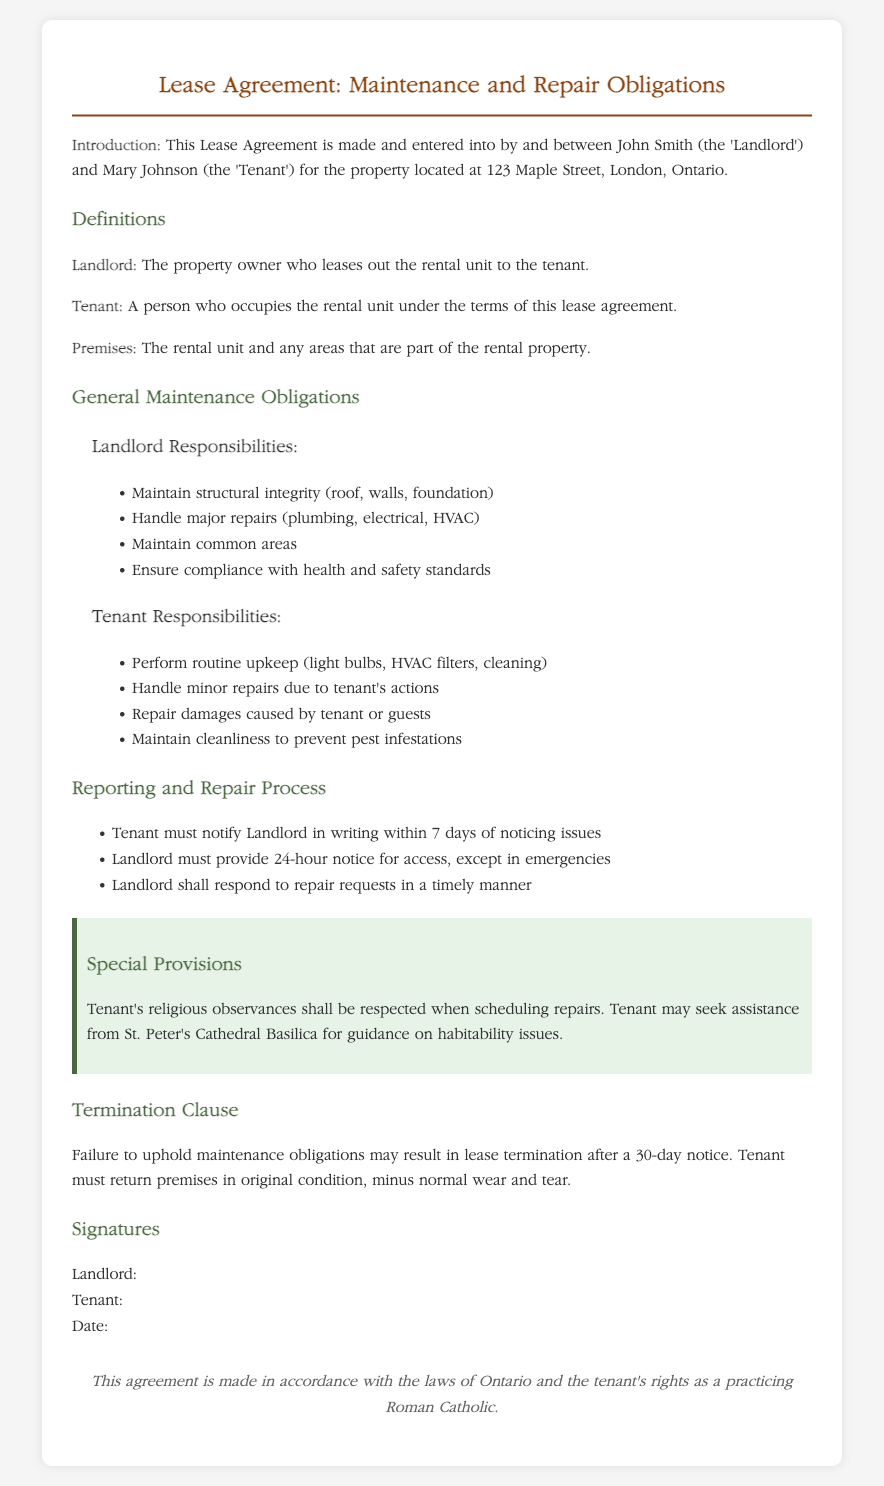What are the names of the landlord and tenant? The document states the landlord is John Smith and the tenant is Mary Johnson.
Answer: John Smith and Mary Johnson What is the address of the property? The property address listed in the document is part of the introduction section.
Answer: 123 Maple Street, London, Ontario What must the tenant do within 7 days of noticing issues? The document specifies that the tenant must notify the landlord in writing about issues.
Answer: Notify in writing Who is responsible for maintaining common areas? This responsibility is outlined under the landlord's obligations in the general maintenance section.
Answer: Landlord What is the notice period for the landlord to provide access for repairs? The relevant section mentions the need for 24-hour notice before landlord access, excluding emergencies.
Answer: 24-hour notice What happens if the maintenance obligations are not upheld? The termination clause indicates that failure to uphold obligations may result in lease termination after a notice period.
Answer: Lease termination What assistance can the tenant seek regarding habitability issues? The special provisions mention that the tenant may seek assistance from a specific church for guidance.
Answer: St. Peter's Cathedral Basilica What must the tenant do before vacating the premises? The termination clause states that the tenant must return the premises in the original condition minus normal wear and tear.
Answer: Return in original condition What color is the special provisions background? The styling of the special provisions section indicates the background color used.
Answer: Light green 